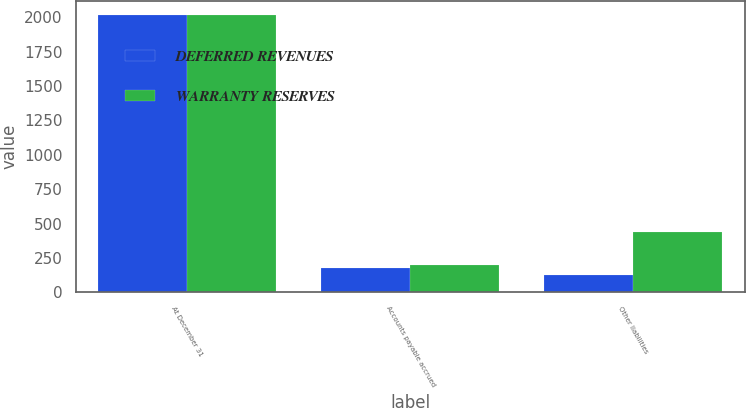<chart> <loc_0><loc_0><loc_500><loc_500><stacked_bar_chart><ecel><fcel>At December 31<fcel>Accounts payable accrued<fcel>Other liabilities<nl><fcel>DEFERRED REVENUES<fcel>2017<fcel>176<fcel>122.8<nl><fcel>WARRANTY RESERVES<fcel>2017<fcel>196.1<fcel>441<nl></chart> 